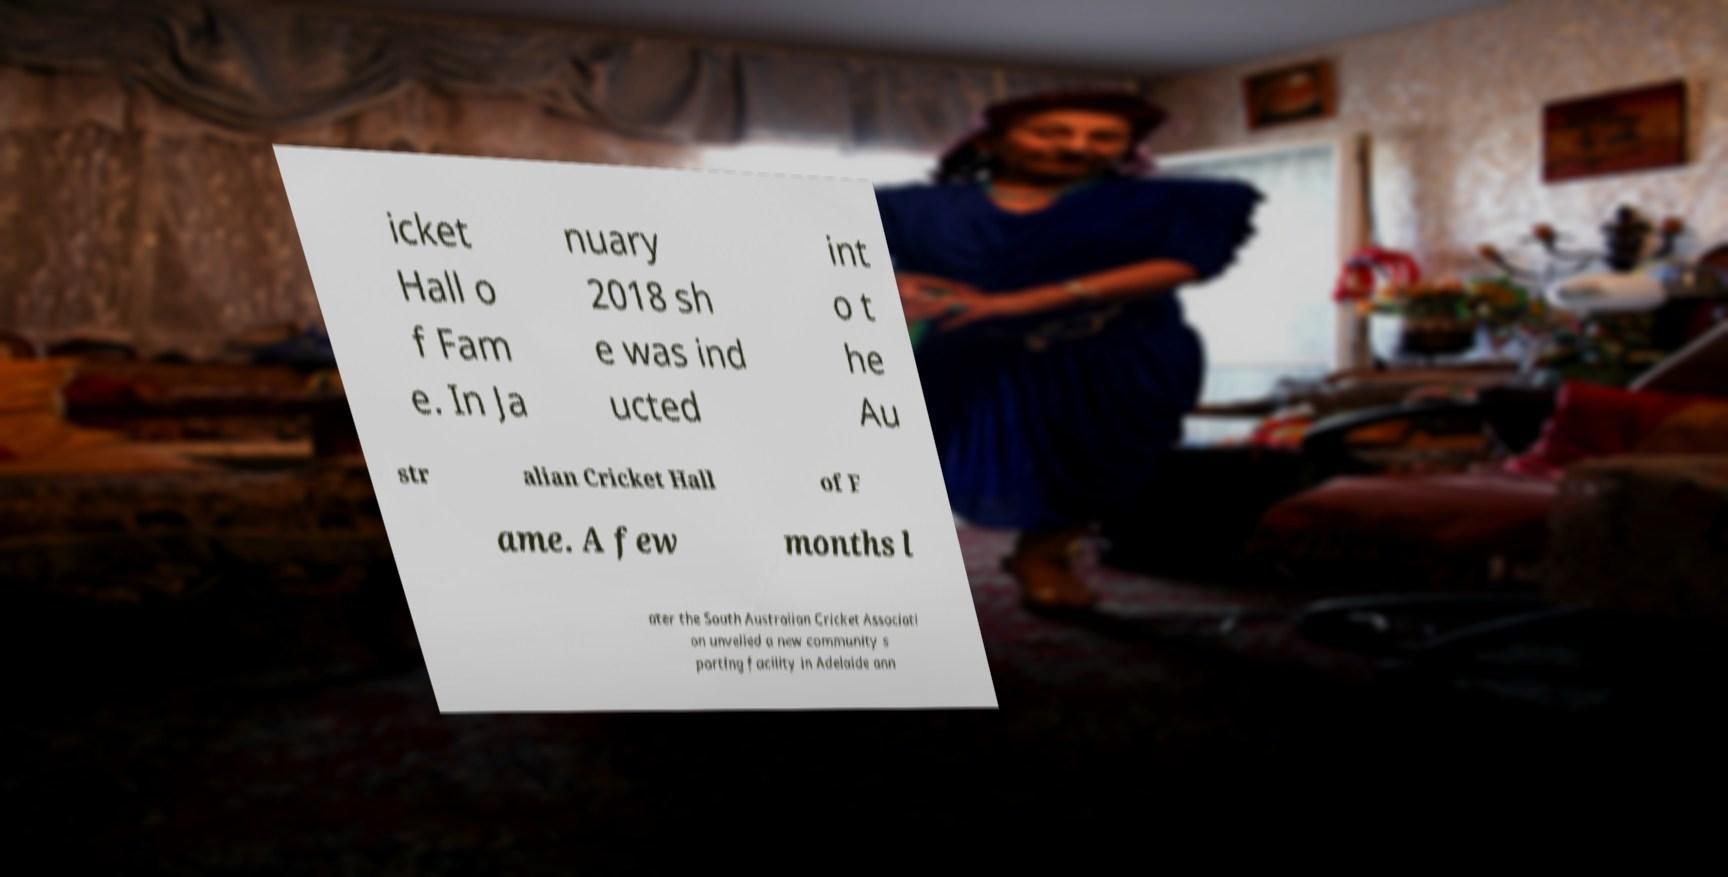For documentation purposes, I need the text within this image transcribed. Could you provide that? icket Hall o f Fam e. In Ja nuary 2018 sh e was ind ucted int o t he Au str alian Cricket Hall of F ame. A few months l ater the South Australian Cricket Associati on unveiled a new community s porting facility in Adelaide ann 